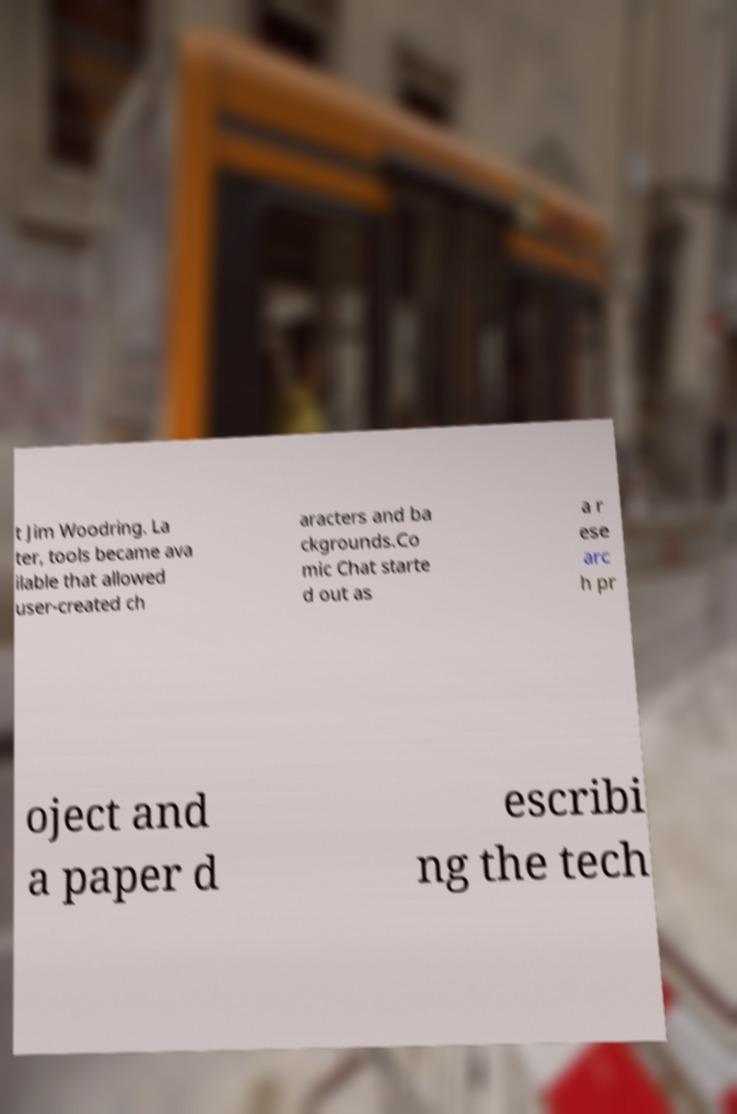Please read and relay the text visible in this image. What does it say? t Jim Woodring. La ter, tools became ava ilable that allowed user-created ch aracters and ba ckgrounds.Co mic Chat starte d out as a r ese arc h pr oject and a paper d escribi ng the tech 